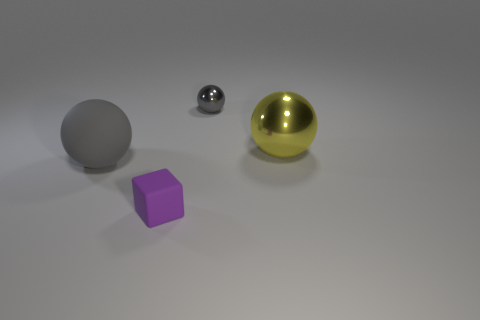Is the block the same color as the big shiny object?
Offer a terse response. No. What size is the gray ball behind the gray sphere in front of the big sphere to the right of the large gray matte object?
Provide a succinct answer. Small. What is the material of the gray object that is the same size as the purple matte block?
Provide a succinct answer. Metal. Are there any purple matte cubes that have the same size as the gray rubber sphere?
Your answer should be very brief. No. There is a rubber object on the left side of the matte cube; is its size the same as the gray metal thing?
Ensure brevity in your answer.  No. There is a object that is both on the right side of the big gray matte ball and to the left of the gray shiny object; what shape is it?
Offer a very short reply. Cube. Are there more tiny gray objects on the right side of the gray metallic sphere than large yellow spheres?
Provide a succinct answer. No. What is the size of the gray ball that is made of the same material as the cube?
Make the answer very short. Large. How many big rubber things have the same color as the tiny shiny object?
Offer a terse response. 1. There is a large object that is behind the big gray sphere; is its color the same as the small ball?
Your answer should be very brief. No. 